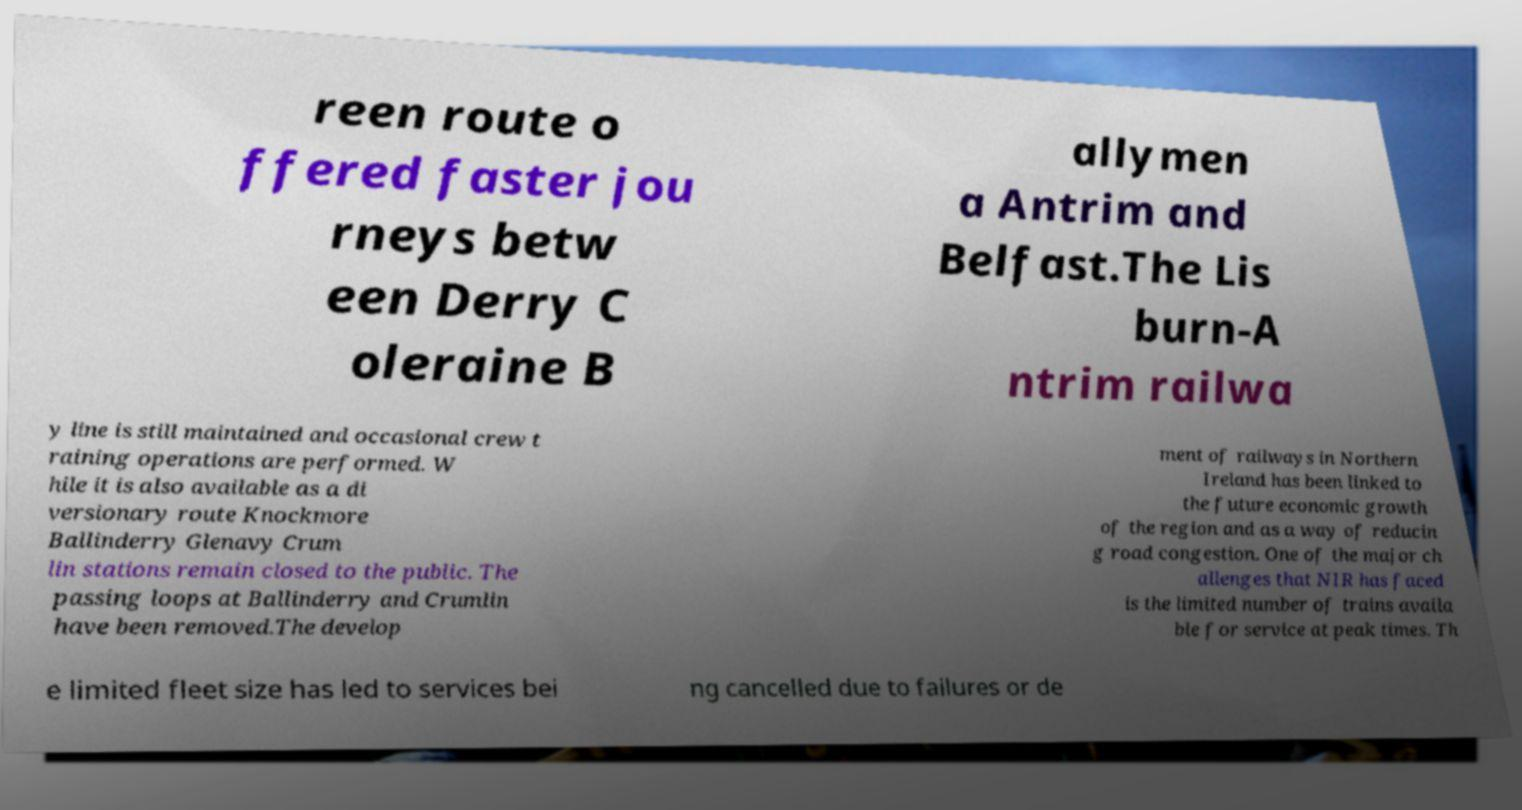Please read and relay the text visible in this image. What does it say? reen route o ffered faster jou rneys betw een Derry C oleraine B allymen a Antrim and Belfast.The Lis burn-A ntrim railwa y line is still maintained and occasional crew t raining operations are performed. W hile it is also available as a di versionary route Knockmore Ballinderry Glenavy Crum lin stations remain closed to the public. The passing loops at Ballinderry and Crumlin have been removed.The develop ment of railways in Northern Ireland has been linked to the future economic growth of the region and as a way of reducin g road congestion. One of the major ch allenges that NIR has faced is the limited number of trains availa ble for service at peak times. Th e limited fleet size has led to services bei ng cancelled due to failures or de 